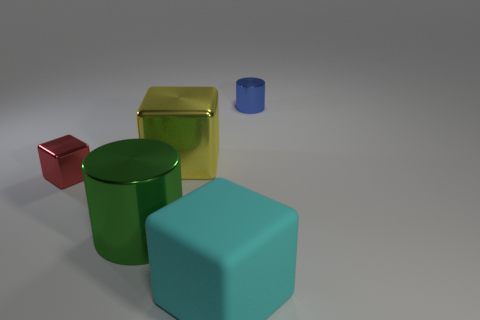Subtract all small cubes. How many cubes are left? 2 Add 1 big objects. How many objects exist? 6 Subtract 3 blocks. How many blocks are left? 0 Subtract all green cylinders. How many cylinders are left? 1 Subtract 0 brown cylinders. How many objects are left? 5 Subtract all cylinders. How many objects are left? 3 Subtract all red cylinders. Subtract all yellow blocks. How many cylinders are left? 2 Subtract all small metallic objects. Subtract all small blue metal cylinders. How many objects are left? 2 Add 5 tiny shiny things. How many tiny shiny things are left? 7 Add 2 tiny yellow cubes. How many tiny yellow cubes exist? 2 